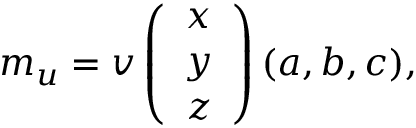Convert formula to latex. <formula><loc_0><loc_0><loc_500><loc_500>m _ { u } = v \left ( \begin{array} { c } { x } \\ { y } \\ { z } \end{array} \right ) ( a , b , c ) ,</formula> 